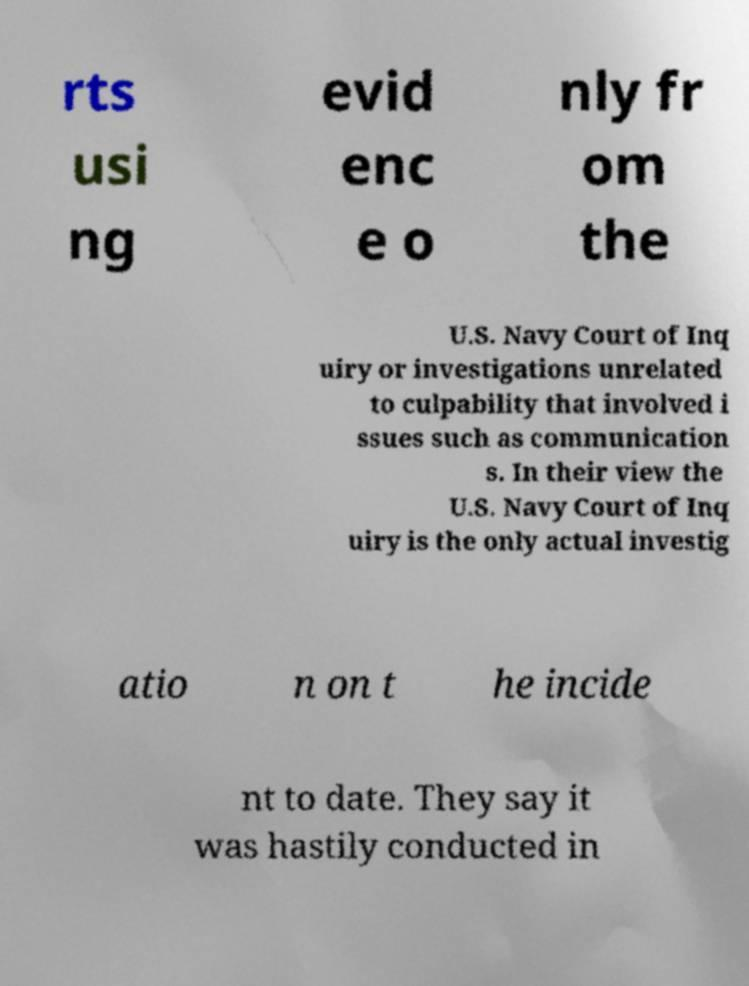Please read and relay the text visible in this image. What does it say? rts usi ng evid enc e o nly fr om the U.S. Navy Court of Inq uiry or investigations unrelated to culpability that involved i ssues such as communication s. In their view the U.S. Navy Court of Inq uiry is the only actual investig atio n on t he incide nt to date. They say it was hastily conducted in 